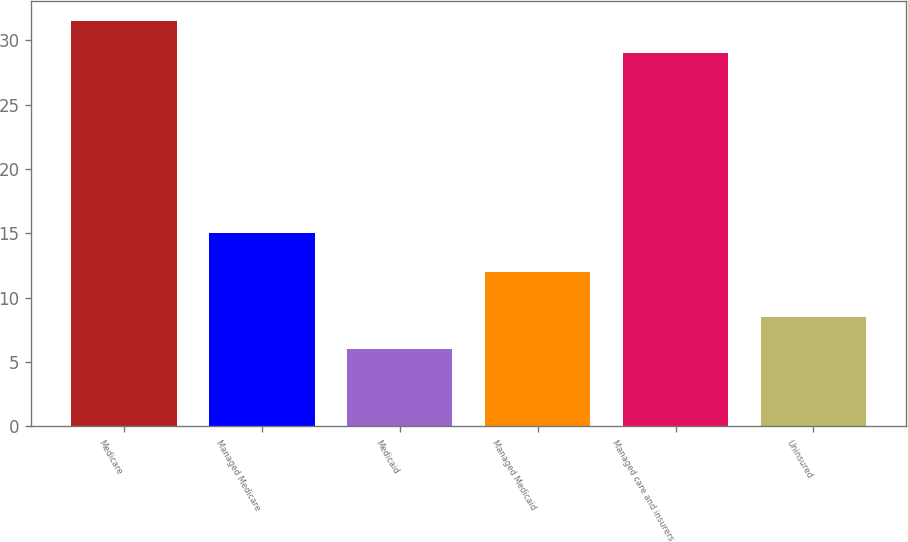Convert chart to OTSL. <chart><loc_0><loc_0><loc_500><loc_500><bar_chart><fcel>Medicare<fcel>Managed Medicare<fcel>Medicaid<fcel>Managed Medicaid<fcel>Managed care and insurers<fcel>Uninsured<nl><fcel>31.5<fcel>15<fcel>6<fcel>12<fcel>29<fcel>8.5<nl></chart> 